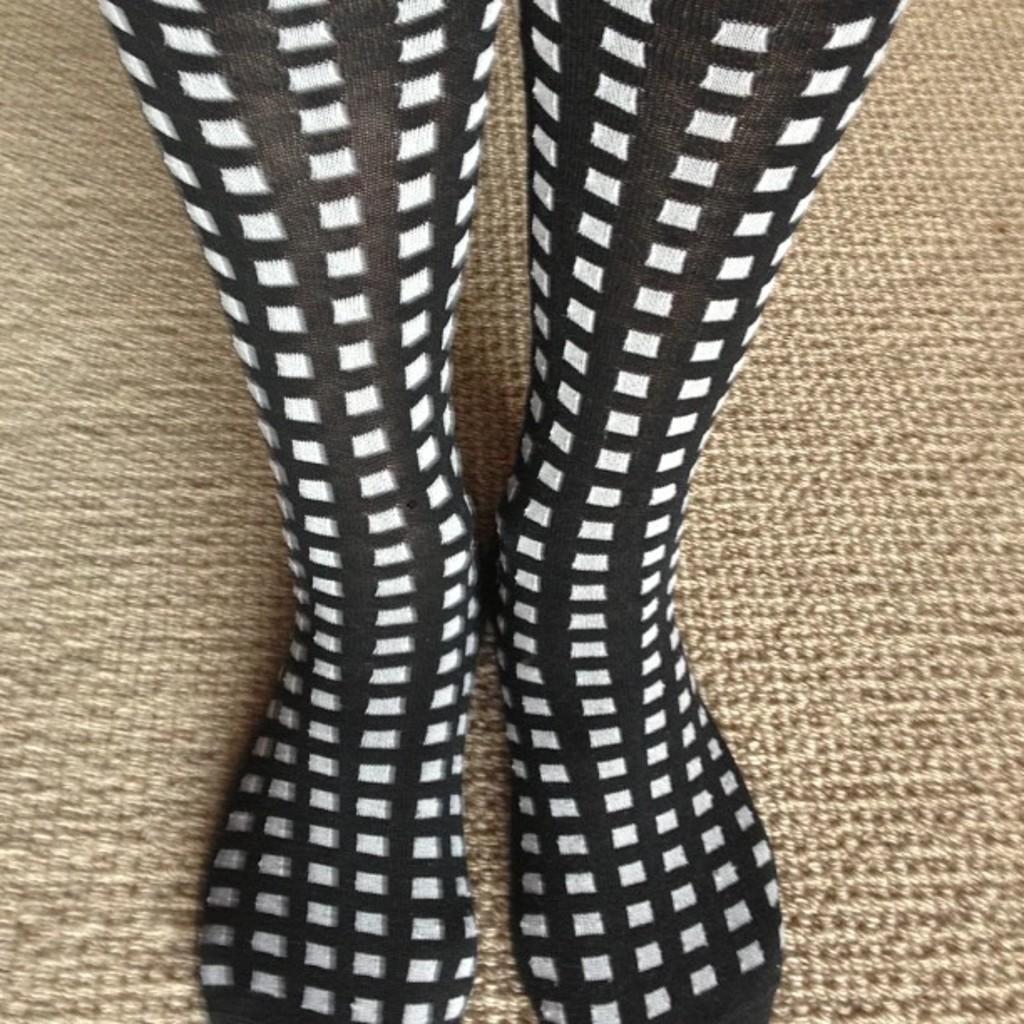Please provide a concise description of this image. In the image we can see a pair of socks, black and white in color. Here we can see the carpet. 